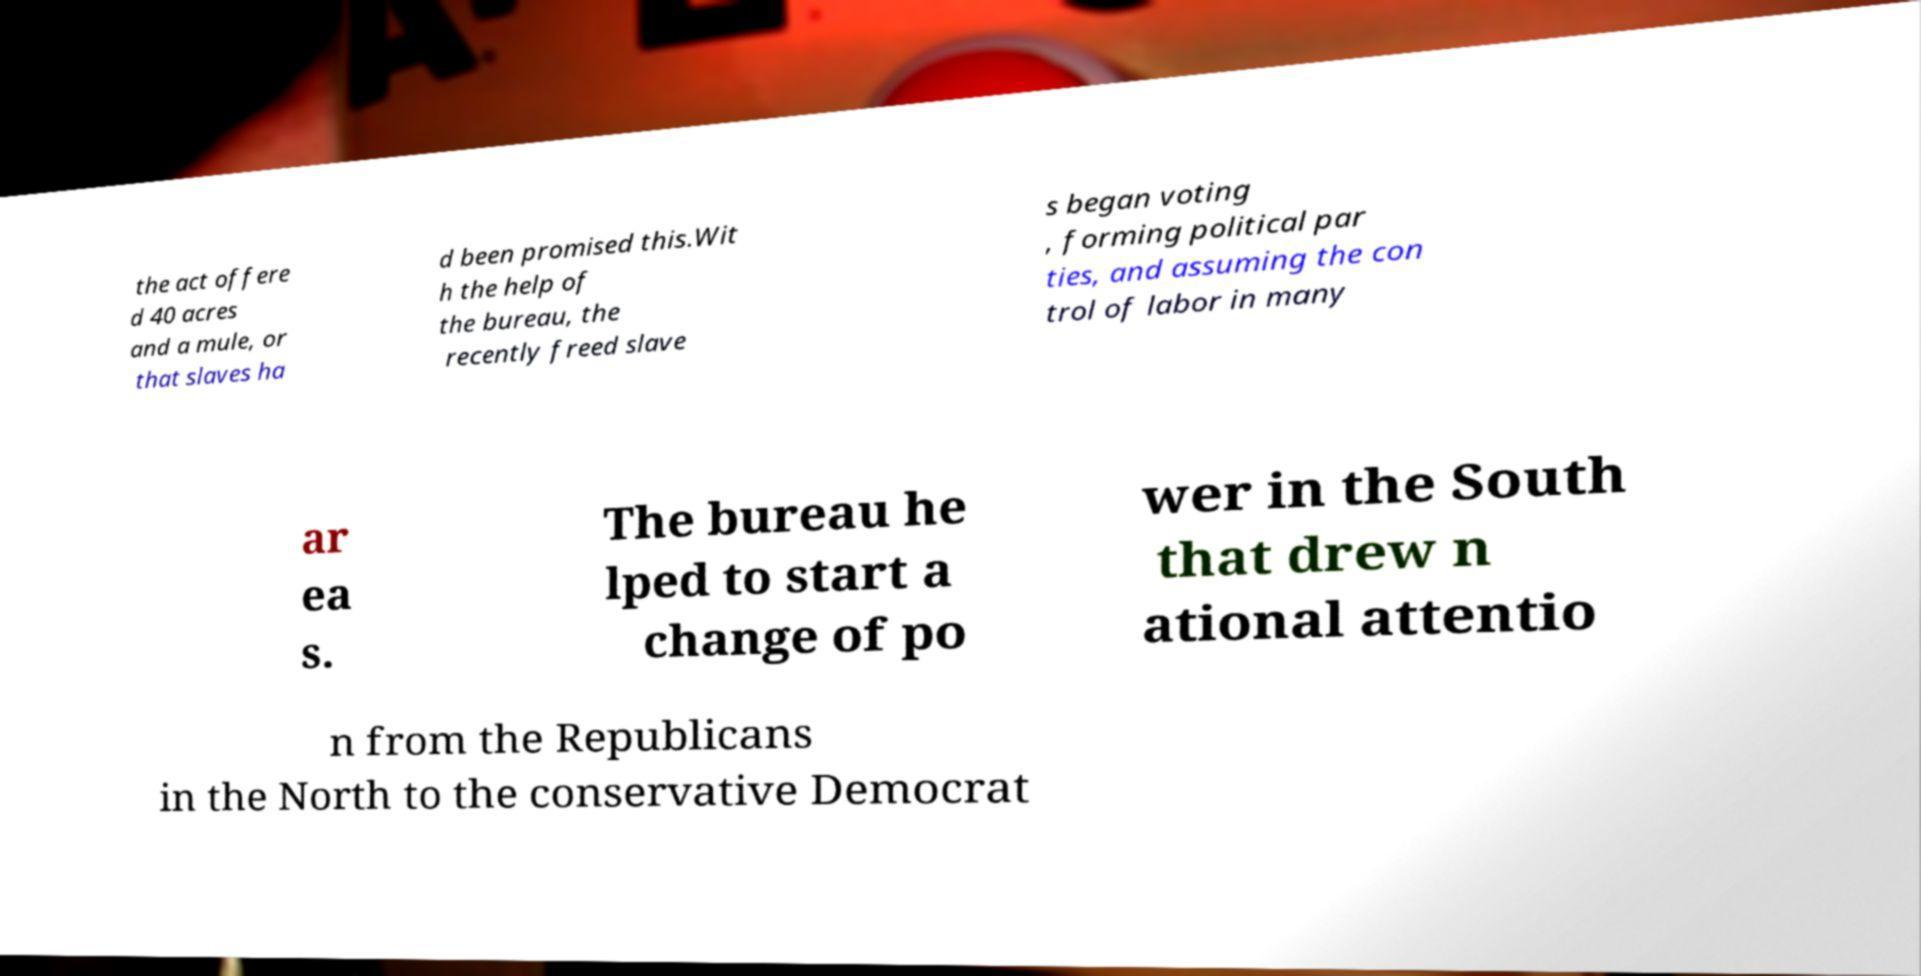There's text embedded in this image that I need extracted. Can you transcribe it verbatim? the act offere d 40 acres and a mule, or that slaves ha d been promised this.Wit h the help of the bureau, the recently freed slave s began voting , forming political par ties, and assuming the con trol of labor in many ar ea s. The bureau he lped to start a change of po wer in the South that drew n ational attentio n from the Republicans in the North to the conservative Democrat 